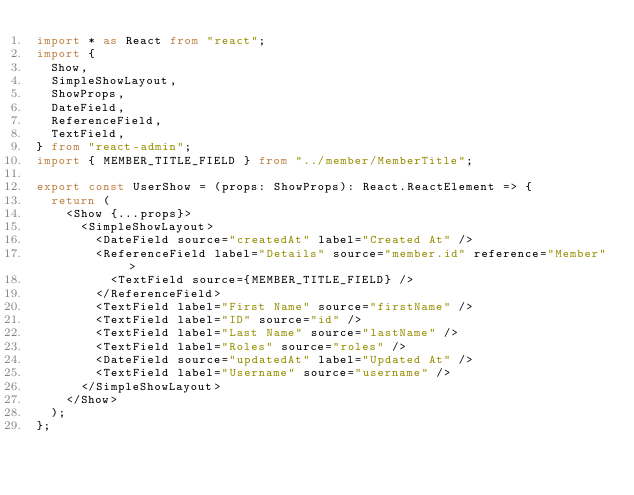<code> <loc_0><loc_0><loc_500><loc_500><_TypeScript_>import * as React from "react";
import {
  Show,
  SimpleShowLayout,
  ShowProps,
  DateField,
  ReferenceField,
  TextField,
} from "react-admin";
import { MEMBER_TITLE_FIELD } from "../member/MemberTitle";

export const UserShow = (props: ShowProps): React.ReactElement => {
  return (
    <Show {...props}>
      <SimpleShowLayout>
        <DateField source="createdAt" label="Created At" />
        <ReferenceField label="Details" source="member.id" reference="Member">
          <TextField source={MEMBER_TITLE_FIELD} />
        </ReferenceField>
        <TextField label="First Name" source="firstName" />
        <TextField label="ID" source="id" />
        <TextField label="Last Name" source="lastName" />
        <TextField label="Roles" source="roles" />
        <DateField source="updatedAt" label="Updated At" />
        <TextField label="Username" source="username" />
      </SimpleShowLayout>
    </Show>
  );
};
</code> 